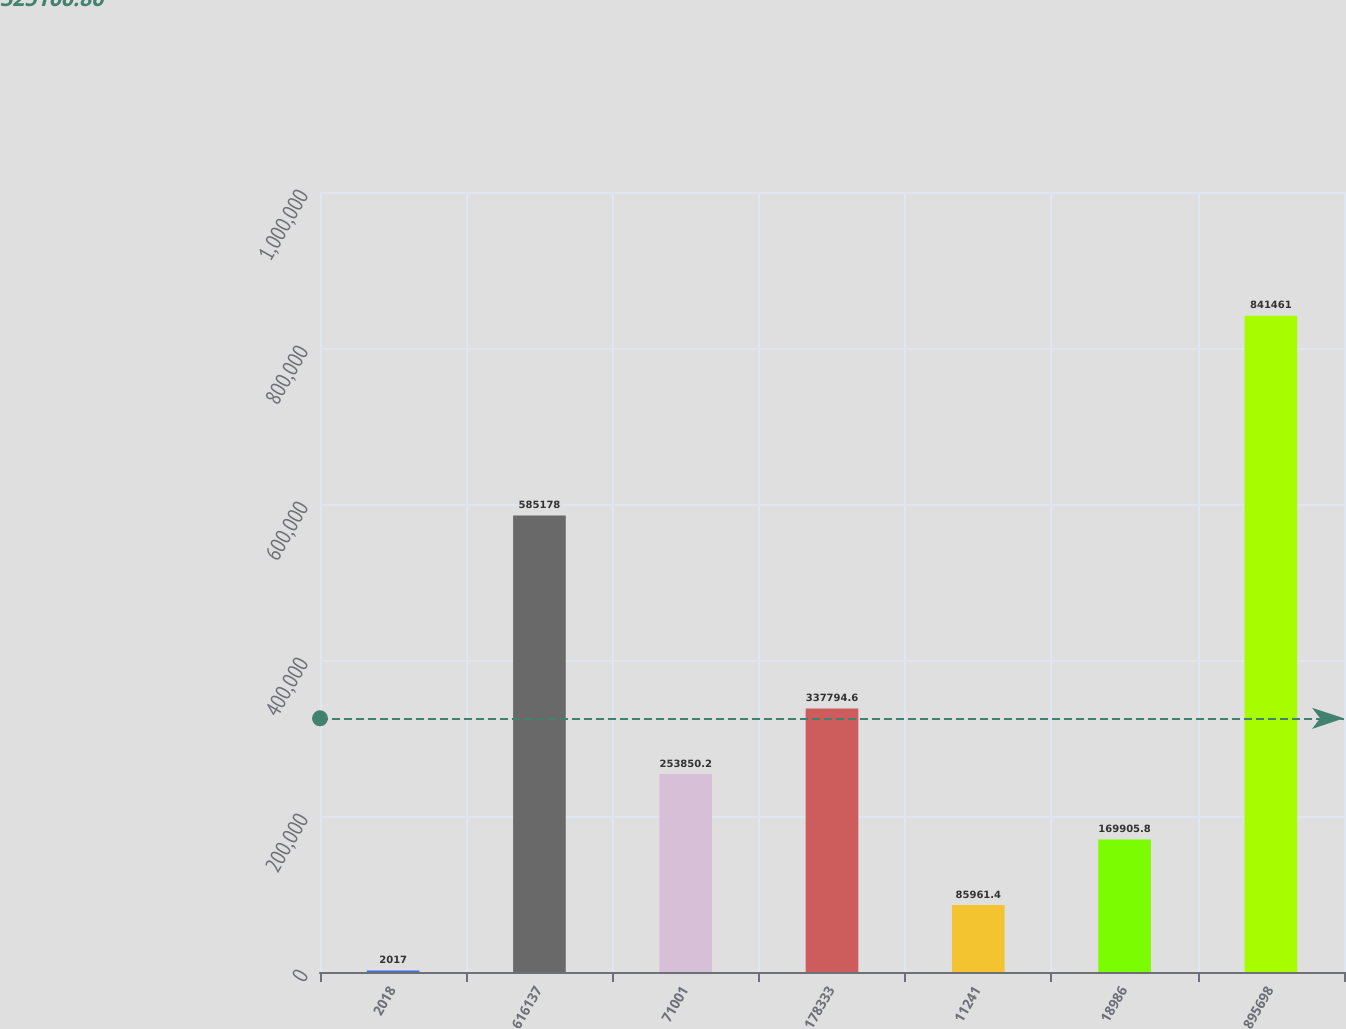Convert chart to OTSL. <chart><loc_0><loc_0><loc_500><loc_500><bar_chart><fcel>2018<fcel>616137<fcel>71001<fcel>178333<fcel>11241<fcel>18986<fcel>895698<nl><fcel>2017<fcel>585178<fcel>253850<fcel>337795<fcel>85961.4<fcel>169906<fcel>841461<nl></chart> 